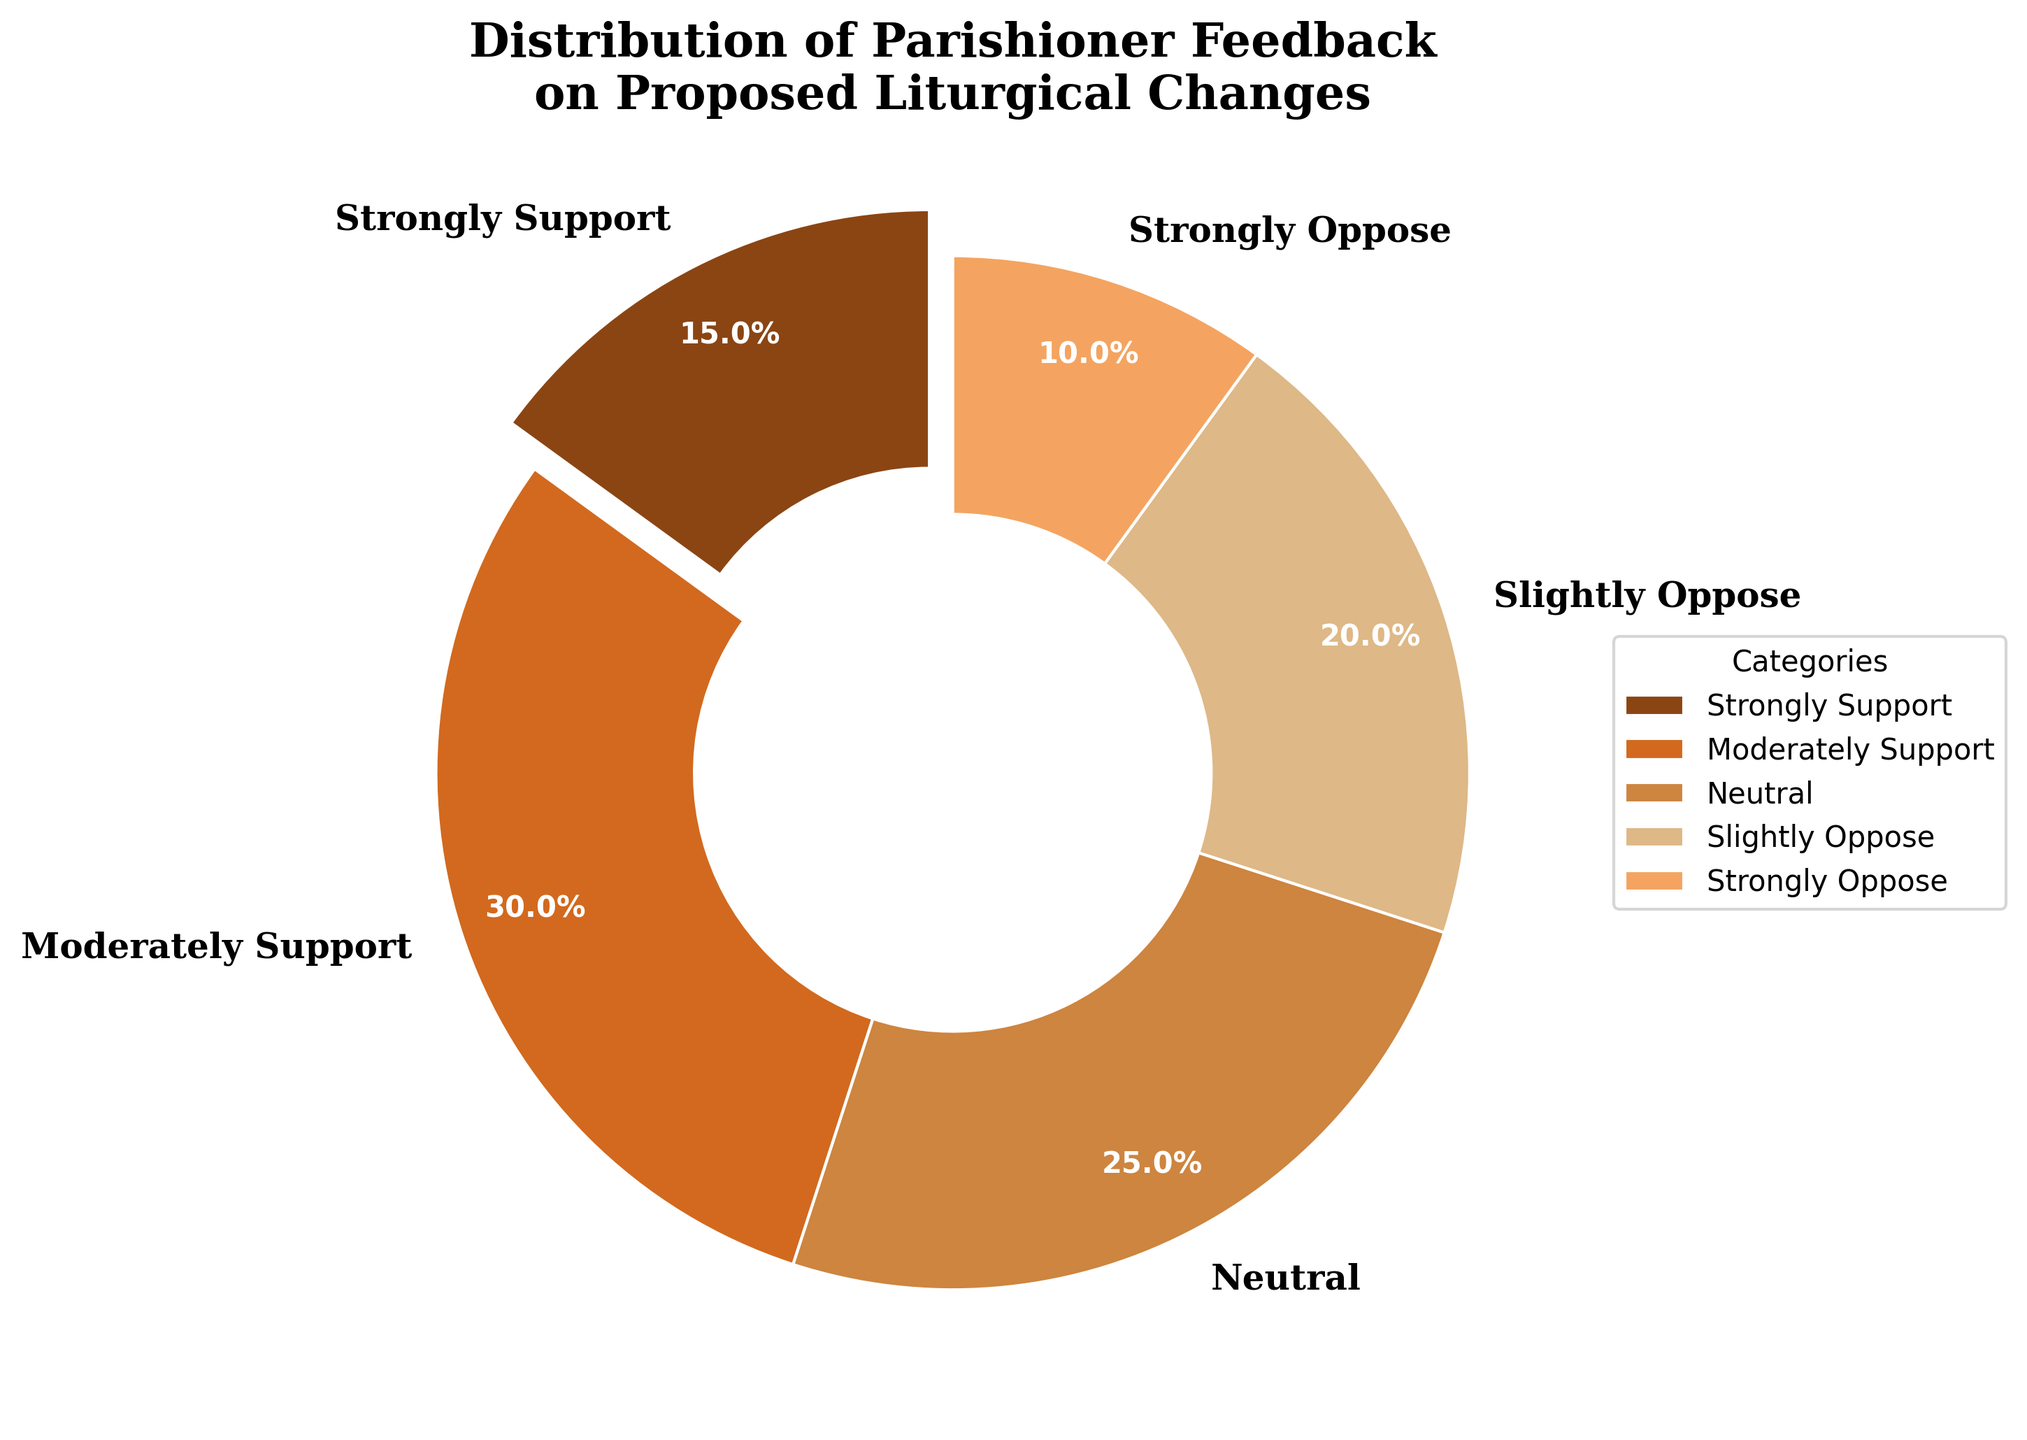What percentage of parishioners support the proposed liturgical changes (both strongly and moderately)? Add the percentages of those who strongly support (15%) and moderately support (30%) to get the total support percentage. 15 + 30 = 45%
Answer: 45% Which category has the highest level of support? Identify the category with the largest percentage. The highest percentage is 30%, which corresponds to the "Moderately Support" category.
Answer: Moderately Support How many categories are displayed in the pie chart? Count the number of different labels in the pie chart. There are five categories labeled in the chart.
Answer: 5 What is the difference in percentage between those who are neutral and those who slightly oppose the changes? Subtract the percentage of those who slightly oppose (20%) from those who are neutral (25%) to find the difference. 25 - 20 = 5%
Answer: 5% Which categories are represented in brown shades? The pie chart uses brown shades for the categories. Identify the categories whose colors are different shades of brown. "Strongly Support", "Moderately Support", "Neutral", "Slightly Oppose", and "Strongly Oppose" are all represented in brown shades.
Answer: Strongly Support, Moderately Support, Neutral, Slightly Oppose, Strongly Oppose What portion of parishioners oppose the changes to any extent? Add the percentages of those who slightly oppose (20%) and strongly oppose (10%) to get the total opposition percentage. 20 + 10 = 30%
Answer: 30% If you combine the percentages of 'Neutral' and 'Moderately Support', what is the sum? Add the percentages of those who are neutral (25%) and those who moderately support (30%) to get the combined percentage. 25 + 30 = 55%
Answer: 55% Among the categories, which one has the smallest representation? Identify the category with the smallest percentage. The smallest percentage is 10%, which corresponds to the "Strongly Oppose" category.
Answer: Strongly Oppose What category does the largest wedge in the pie chart represent? Look for the largest wedge in the pie chart, which has the largest percentage. The largest wedge represents the "Moderately Support" category with 30%.
Answer: Moderately Support 